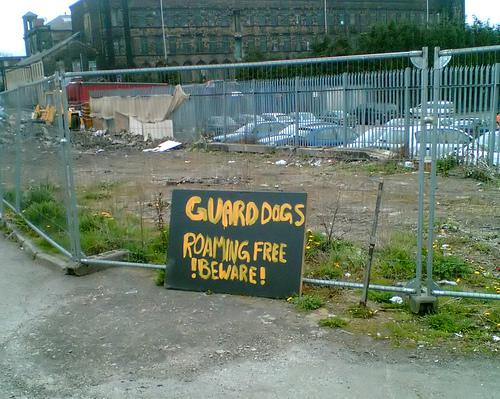Question: what is the metal object in the foreground?
Choices:
A. Fence.
B. Bench.
C. Statue.
D. Lamp post.
Answer with the letter. Answer: A Question: what does the black sign against the fence saying?
Choices:
A. No soliciting.
B. No smoking.
C. Guard dogs roaming free beware.
D. No unauthorized personnel.
Answer with the letter. Answer: C Question: what is in the background of the photo on the left side?
Choices:
A. Mountain.
B. Building.
C. Statue.
D. Tree.
Answer with the letter. Answer: B Question: where are the vehicles?
Choices:
A. In the garage.
B. Beyond the fence.
C. In front of the fence.
D. On the highway to the left.
Answer with the letter. Answer: B Question: how many black signs are in the picture?
Choices:
A. Two.
B. Three.
C. One.
D. Four.
Answer with the letter. Answer: C Question: where is this taking place?
Choices:
A. France.
B. Near a fence.
C. London.
D. Switzerland.
Answer with the letter. Answer: B 